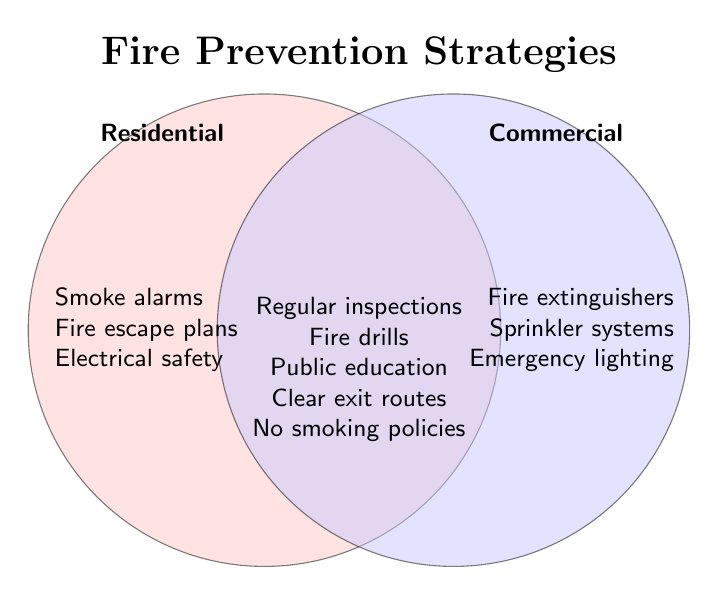Which category has "Smoke alarms"? "Smoke alarms" are listed under the Residential category on the left.
Answer: Residential What are the common elements for both Residential and Commercial? In the overlapping area of the Venn Diagram, the common elements are Regular inspections, Fire drills, Public education, Clear exit routes, and No smoking policies.
Answer: Regular inspections, Fire drills, Public education, Clear exit routes, No smoking policies Which elements are specific to the Commercial category? The elements specific to Commercial are found on the right side: Fire extinguishers, Sprinkler systems, and Emergency lighting.
Answer: Fire extinguishers, Sprinkler systems, Emergency lighting Compare the number of unique elements in Residential and Commercial categories. Which has more? Residential has three unique elements whereas Commercial also has three unique elements. Since they are equal, neither has more.
Answer: Equal Identify an element related to fire prevention that is common to both categories and involves education. The element "Public education" is listed in the overlapping area of the Venn Diagram and involves education.
Answer: Public education How many total elements are listed in the figure? Adding all unique elements and common elements: 3 (Residential) + 3 (Commercial) + 5 (Both categories) = 11.
Answer: 11 